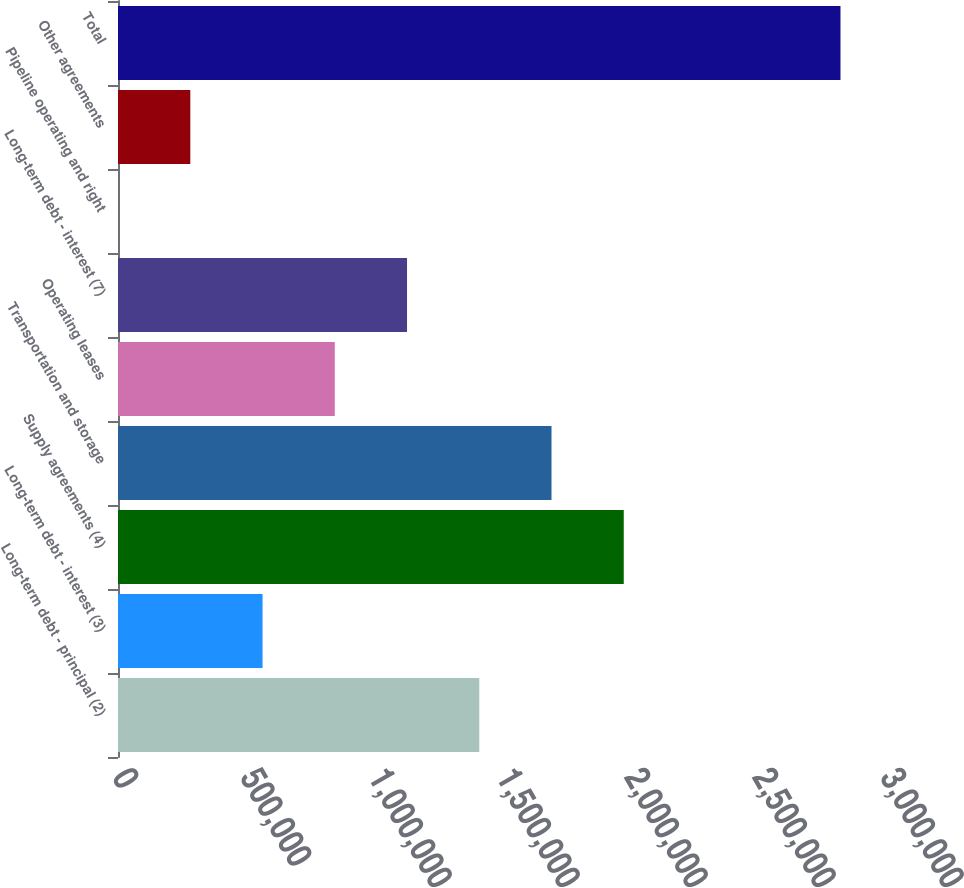Convert chart to OTSL. <chart><loc_0><loc_0><loc_500><loc_500><bar_chart><fcel>Long-term debt - principal (2)<fcel>Long-term debt - interest (3)<fcel>Supply agreements (4)<fcel>Transportation and storage<fcel>Operating leases<fcel>Long-term debt - interest (7)<fcel>Pipeline operating and right<fcel>Other agreements<fcel>Total<nl><fcel>1.41121e+06<fcel>564645<fcel>1.97559e+06<fcel>1.6934e+06<fcel>846835<fcel>1.12902e+06<fcel>266<fcel>282456<fcel>2.82216e+06<nl></chart> 